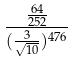<formula> <loc_0><loc_0><loc_500><loc_500>\frac { \frac { 6 4 } { 2 5 2 } } { ( \frac { 3 } { \sqrt { 1 0 } } ) ^ { 4 7 6 } }</formula> 